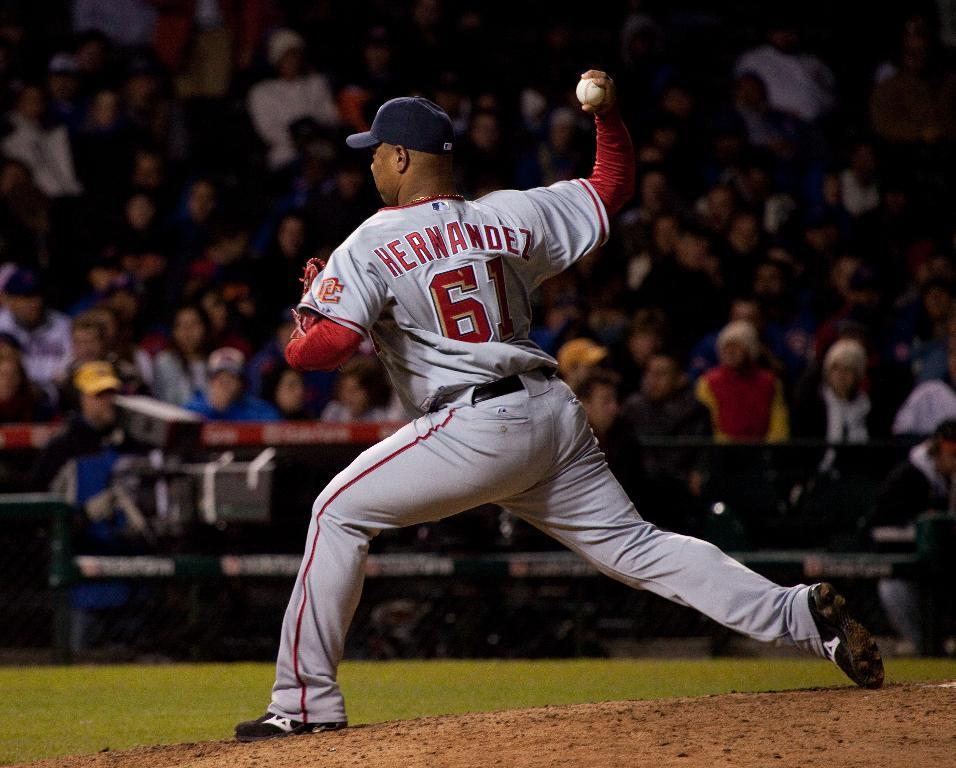Provide a one-sentence caption for the provided image. The pitcher in the picture is named Hernandez. 